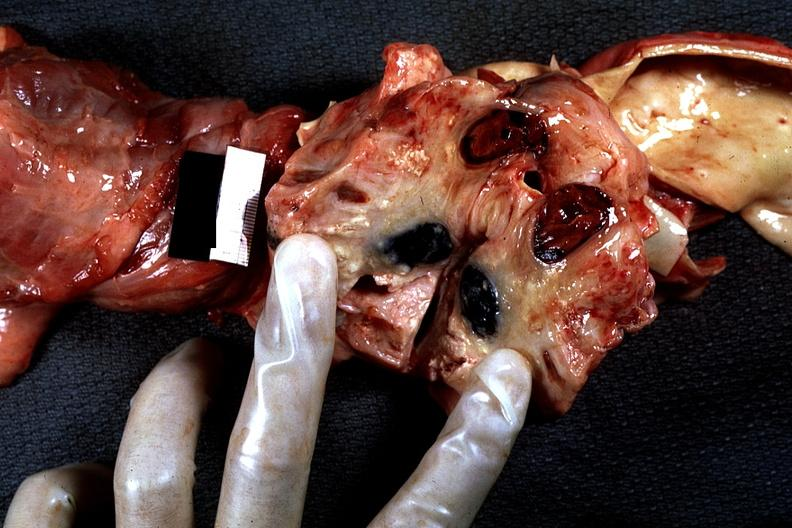where is this?
Answer the question using a single word or phrase. Thorax 